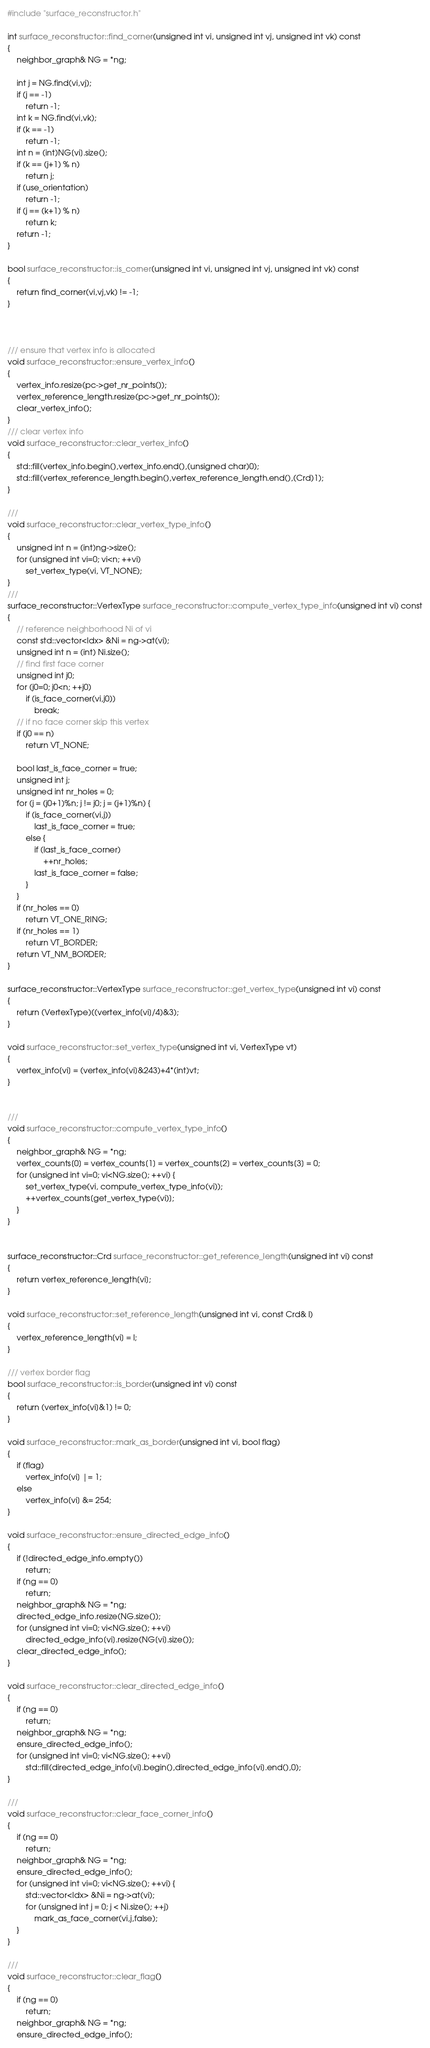<code> <loc_0><loc_0><loc_500><loc_500><_C++_>
#include "surface_reconstructor.h"

int surface_reconstructor::find_corner(unsigned int vi, unsigned int vj, unsigned int vk) const
{
	neighbor_graph& NG = *ng;

	int j = NG.find(vi,vj);
	if (j == -1)
		return -1;
	int k = NG.find(vi,vk);
	if (k == -1)
		return -1;
	int n = (int)NG[vi].size();
	if (k == (j+1) % n)
		return j;
	if (use_orientation)
		return -1;
	if (j == (k+1) % n)
		return k;
	return -1;
}

bool surface_reconstructor::is_corner(unsigned int vi, unsigned int vj, unsigned int vk) const
{
	return find_corner(vi,vj,vk) != -1;
}



/// ensure that vertex info is allocated
void surface_reconstructor::ensure_vertex_info()
{
	vertex_info.resize(pc->get_nr_points());
	vertex_reference_length.resize(pc->get_nr_points());
	clear_vertex_info();
}
/// clear vertex info
void surface_reconstructor::clear_vertex_info()
{
	std::fill(vertex_info.begin(),vertex_info.end(),(unsigned char)0);
	std::fill(vertex_reference_length.begin(),vertex_reference_length.end(),(Crd)1);
}

///
void surface_reconstructor::clear_vertex_type_info()
{
	unsigned int n = (int)ng->size();
	for (unsigned int vi=0; vi<n; ++vi)
		set_vertex_type(vi, VT_NONE);
}
///
surface_reconstructor::VertexType surface_reconstructor::compute_vertex_type_info(unsigned int vi) const
{
	// reference neighborhood Ni of vi
	const std::vector<Idx> &Ni = ng->at(vi);
	unsigned int n = (int) Ni.size();
	// find first face corner
	unsigned int j0;
	for (j0=0; j0<n; ++j0)
		if (is_face_corner(vi,j0))
			break;
	// if no face corner skip this vertex
	if (j0 == n)
		return VT_NONE;

	bool last_is_face_corner = true;
	unsigned int j;
	unsigned int nr_holes = 0;
	for (j = (j0+1)%n; j != j0; j = (j+1)%n) {
		if (is_face_corner(vi,j))
			last_is_face_corner = true;
		else {
			if (last_is_face_corner)
				++nr_holes;
			last_is_face_corner = false;
		}
	}
	if (nr_holes == 0)
		return VT_ONE_RING;
	if (nr_holes == 1)
		return VT_BORDER;
	return VT_NM_BORDER;
}

surface_reconstructor::VertexType surface_reconstructor::get_vertex_type(unsigned int vi) const
{
	return (VertexType)((vertex_info[vi]/4)&3);
}

void surface_reconstructor::set_vertex_type(unsigned int vi, VertexType vt)
{
	vertex_info[vi] = (vertex_info[vi]&243)+4*(int)vt;
}


///
void surface_reconstructor::compute_vertex_type_info()
{
	neighbor_graph& NG = *ng;
	vertex_counts[0] = vertex_counts[1] = vertex_counts[2] = vertex_counts[3] = 0;
	for (unsigned int vi=0; vi<NG.size(); ++vi) {
		set_vertex_type(vi, compute_vertex_type_info(vi));
		++vertex_counts[get_vertex_type(vi)];
	}
}


surface_reconstructor::Crd surface_reconstructor::get_reference_length(unsigned int vi) const
{
	return vertex_reference_length[vi];
}

void surface_reconstructor::set_reference_length(unsigned int vi, const Crd& l)
{
	vertex_reference_length[vi] = l;
}

/// vertex border flag
bool surface_reconstructor::is_border(unsigned int vi) const
{
	return (vertex_info[vi]&1) != 0;
}

void surface_reconstructor::mark_as_border(unsigned int vi, bool flag)
{
	if (flag)
		vertex_info[vi] |= 1;
	else
		vertex_info[vi] &= 254;
}

void surface_reconstructor::ensure_directed_edge_info()
{
	if (!directed_edge_info.empty())
		return;
	if (ng == 0)
		return;
	neighbor_graph& NG = *ng;
	directed_edge_info.resize(NG.size());
	for (unsigned int vi=0; vi<NG.size(); ++vi)
		directed_edge_info[vi].resize(NG[vi].size());
	clear_directed_edge_info();
}

void surface_reconstructor::clear_directed_edge_info()
{
	if (ng == 0)
		return;
	neighbor_graph& NG = *ng;
	ensure_directed_edge_info();
	for (unsigned int vi=0; vi<NG.size(); ++vi)
		std::fill(directed_edge_info[vi].begin(),directed_edge_info[vi].end(),0);
}

///
void surface_reconstructor::clear_face_corner_info()
{
	if (ng == 0)
		return;
	neighbor_graph& NG = *ng;
	ensure_directed_edge_info();
	for (unsigned int vi=0; vi<NG.size(); ++vi) {
		std::vector<Idx> &Ni = ng->at(vi);
		for (unsigned int j = 0; j < Ni.size(); ++j)
			mark_as_face_corner(vi,j,false);
	}
}

///
void surface_reconstructor::clear_flag()
{
	if (ng == 0)
		return;
	neighbor_graph& NG = *ng;
	ensure_directed_edge_info();</code> 